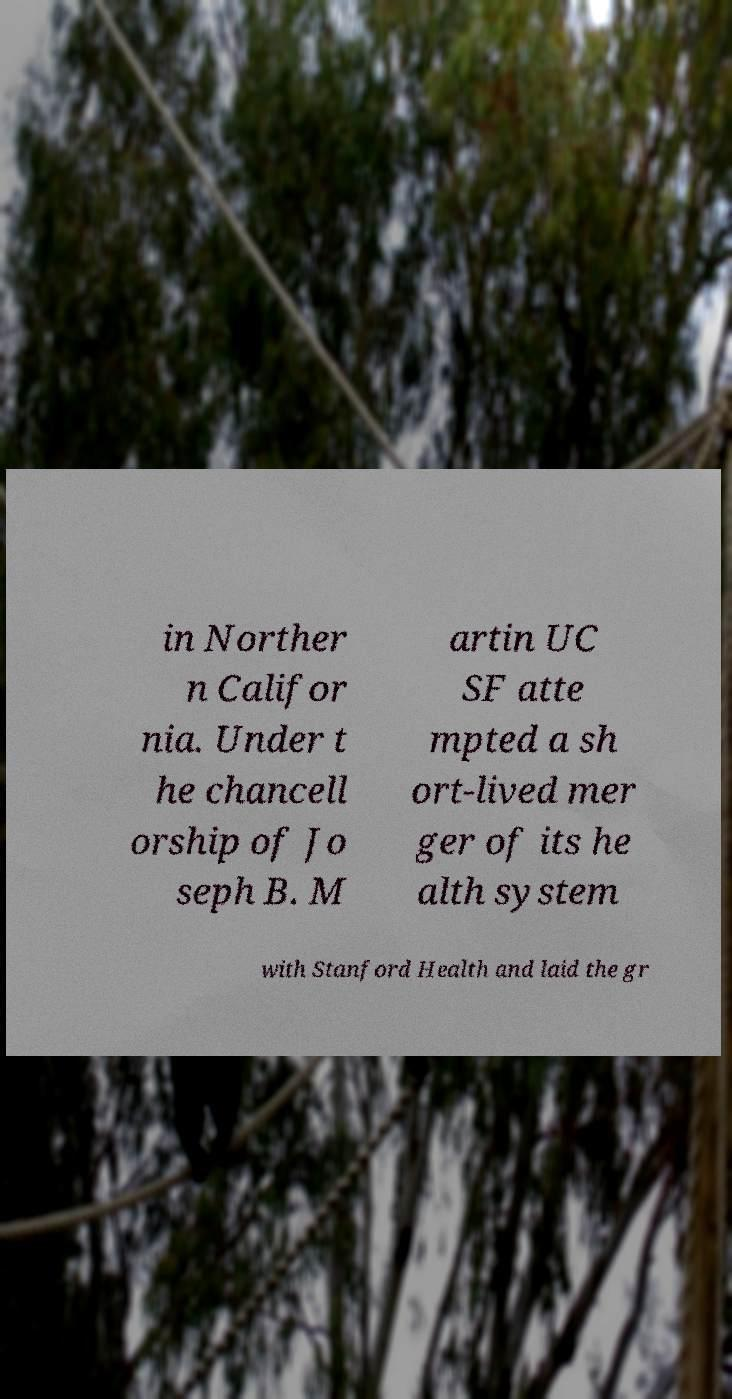Can you read and provide the text displayed in the image?This photo seems to have some interesting text. Can you extract and type it out for me? in Norther n Califor nia. Under t he chancell orship of Jo seph B. M artin UC SF atte mpted a sh ort-lived mer ger of its he alth system with Stanford Health and laid the gr 